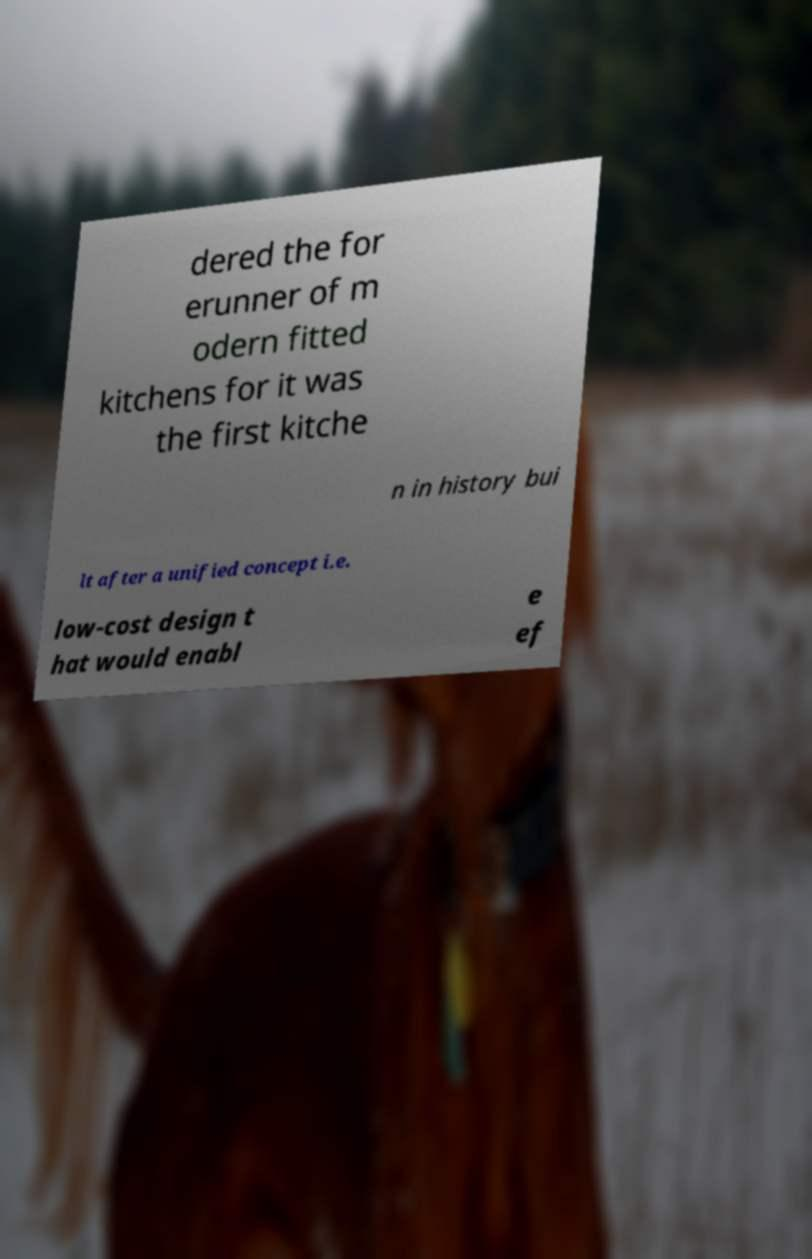Could you assist in decoding the text presented in this image and type it out clearly? dered the for erunner of m odern fitted kitchens for it was the first kitche n in history bui lt after a unified concept i.e. low-cost design t hat would enabl e ef 